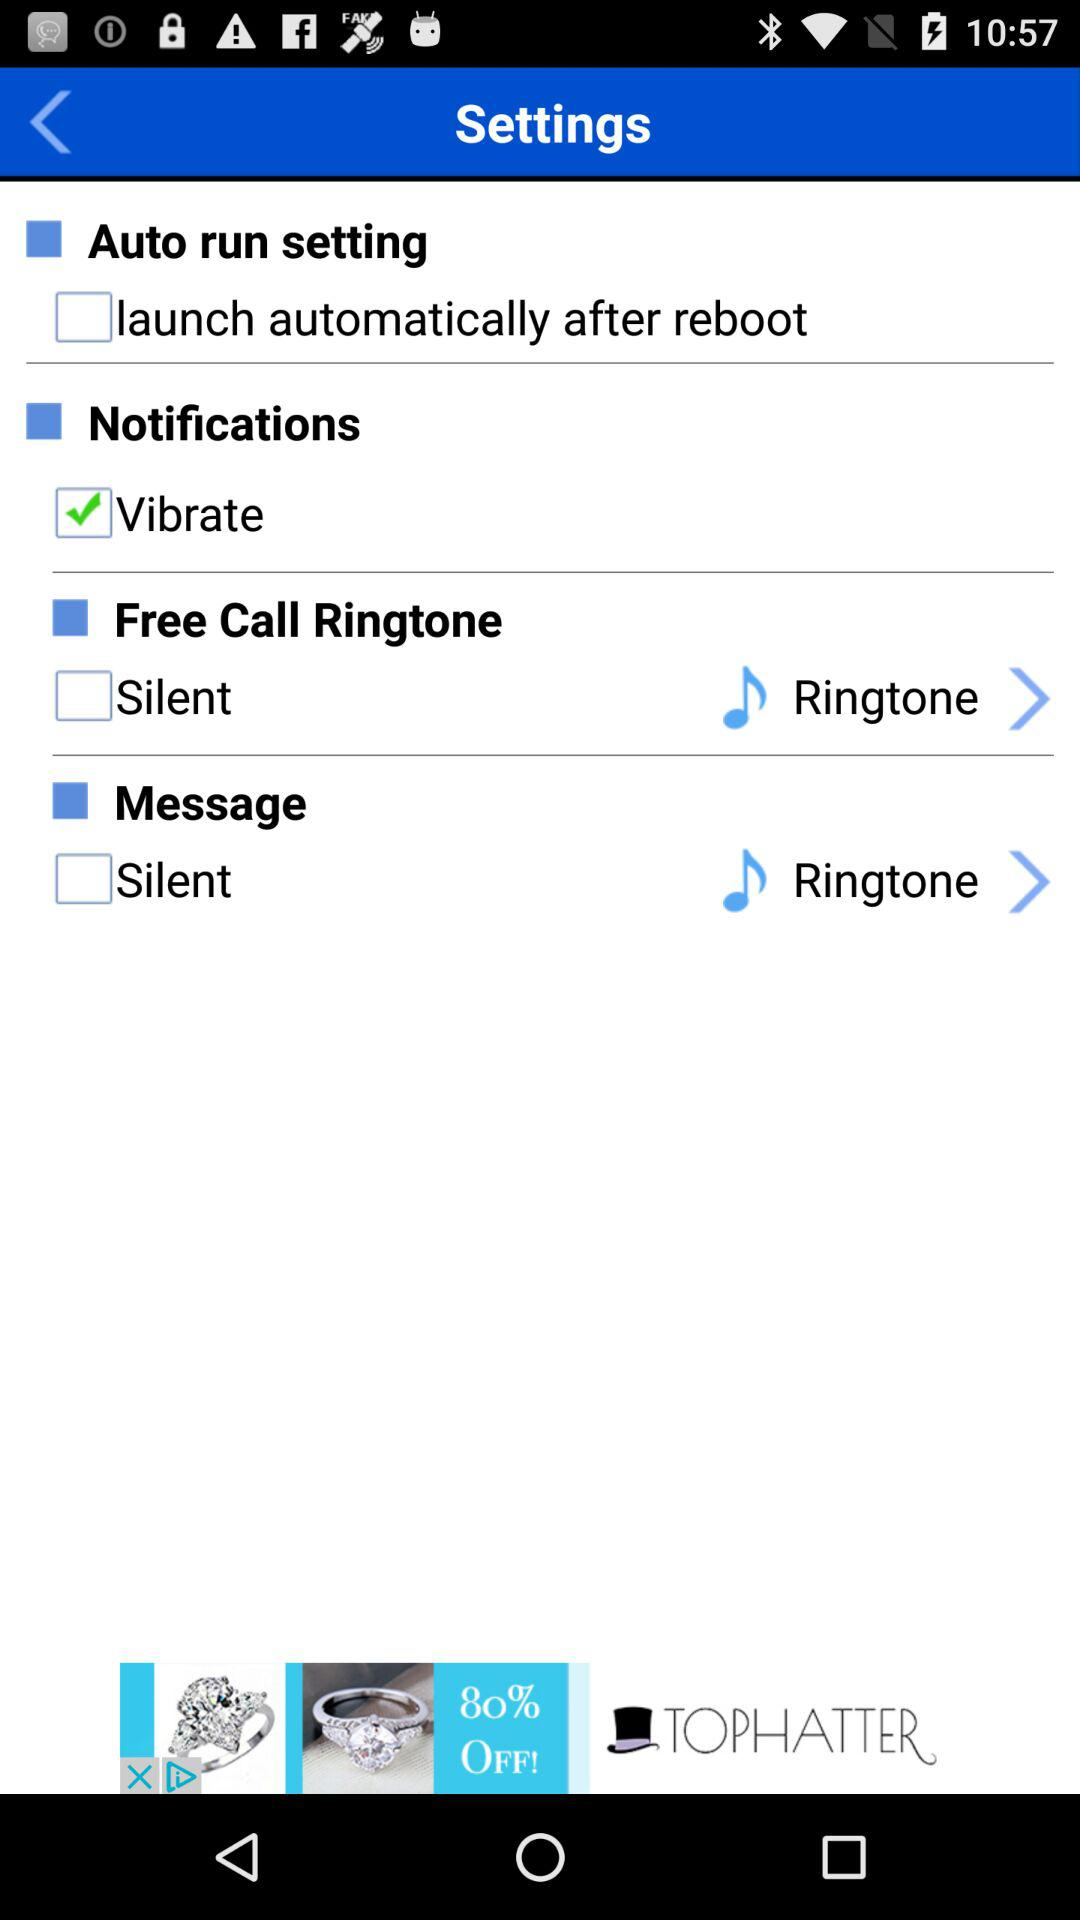How many items are in the settings menu?
Answer the question using a single word or phrase. 4 